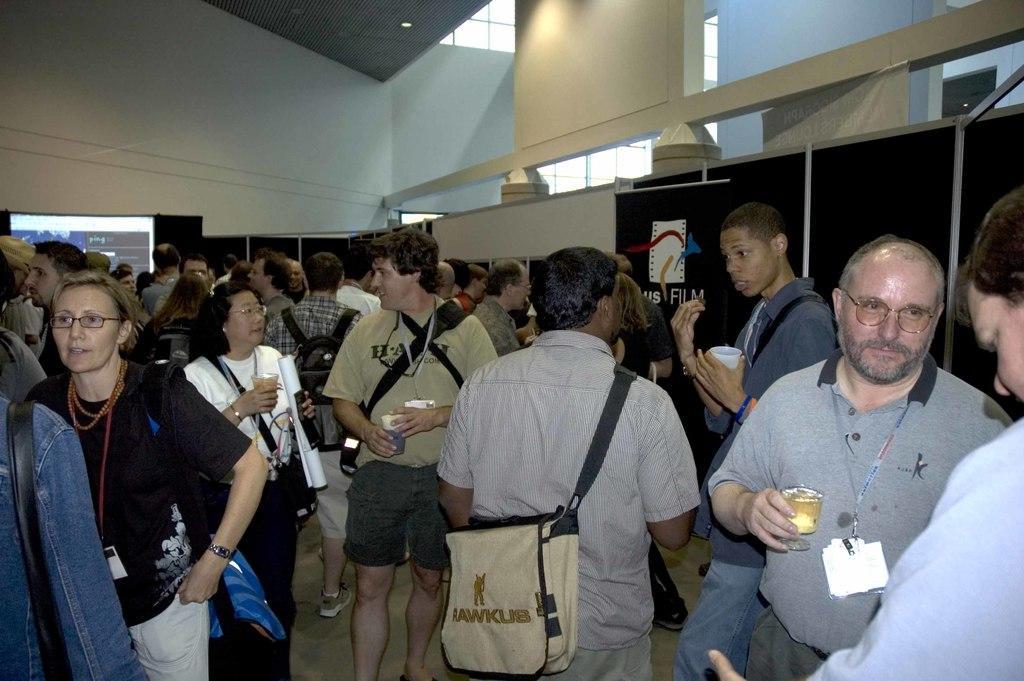Could you give a brief overview of what you see in this image? In the image we can see there are many people standing around, they are wearing clothes and some of them are wearing spectacles, carrying bags and holding objects in their hands. Here we can see the poster, projected screen and the wall. 